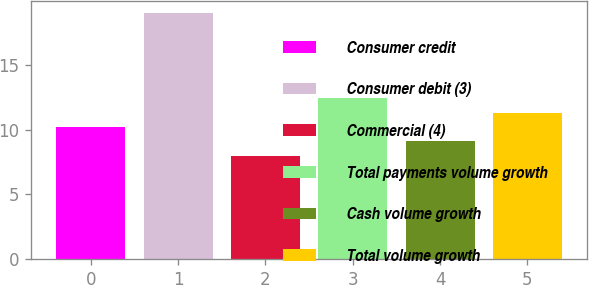Convert chart to OTSL. <chart><loc_0><loc_0><loc_500><loc_500><bar_chart><fcel>Consumer credit<fcel>Consumer debit (3)<fcel>Commercial (4)<fcel>Total payments volume growth<fcel>Cash volume growth<fcel>Total volume growth<nl><fcel>10.2<fcel>19<fcel>8<fcel>12.4<fcel>9.1<fcel>11.3<nl></chart> 